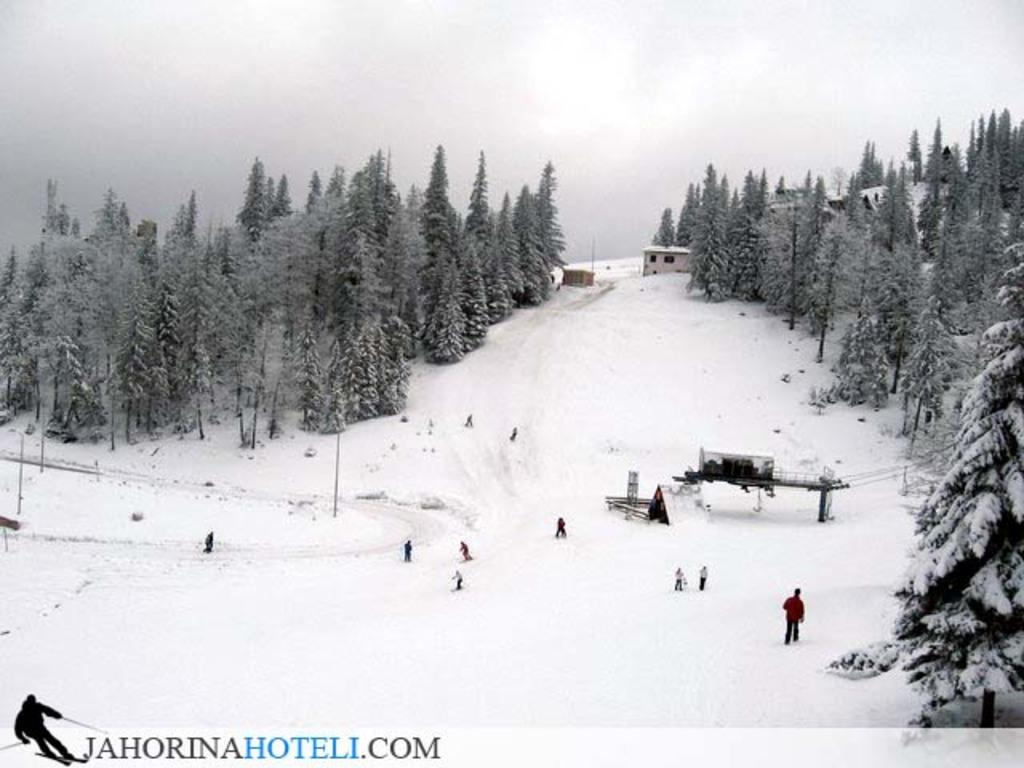What is the primary setting of the image? The primary setting of the image is on the snow. What type of natural elements can be seen in the image? There are trees in the image. What man-made structures are present in the image? There are poles and houses in the image. What other objects can be seen in the image? There are other objects in the image, but their specific details are not mentioned in the facts. What is visible in the background of the image? The sky with clouds is visible in the background of the image. What type of mark can be seen on the trees in the image? There is no mention of any marks on the trees in the image. What sound do the bells make in the image? There are no bells present in the image. 